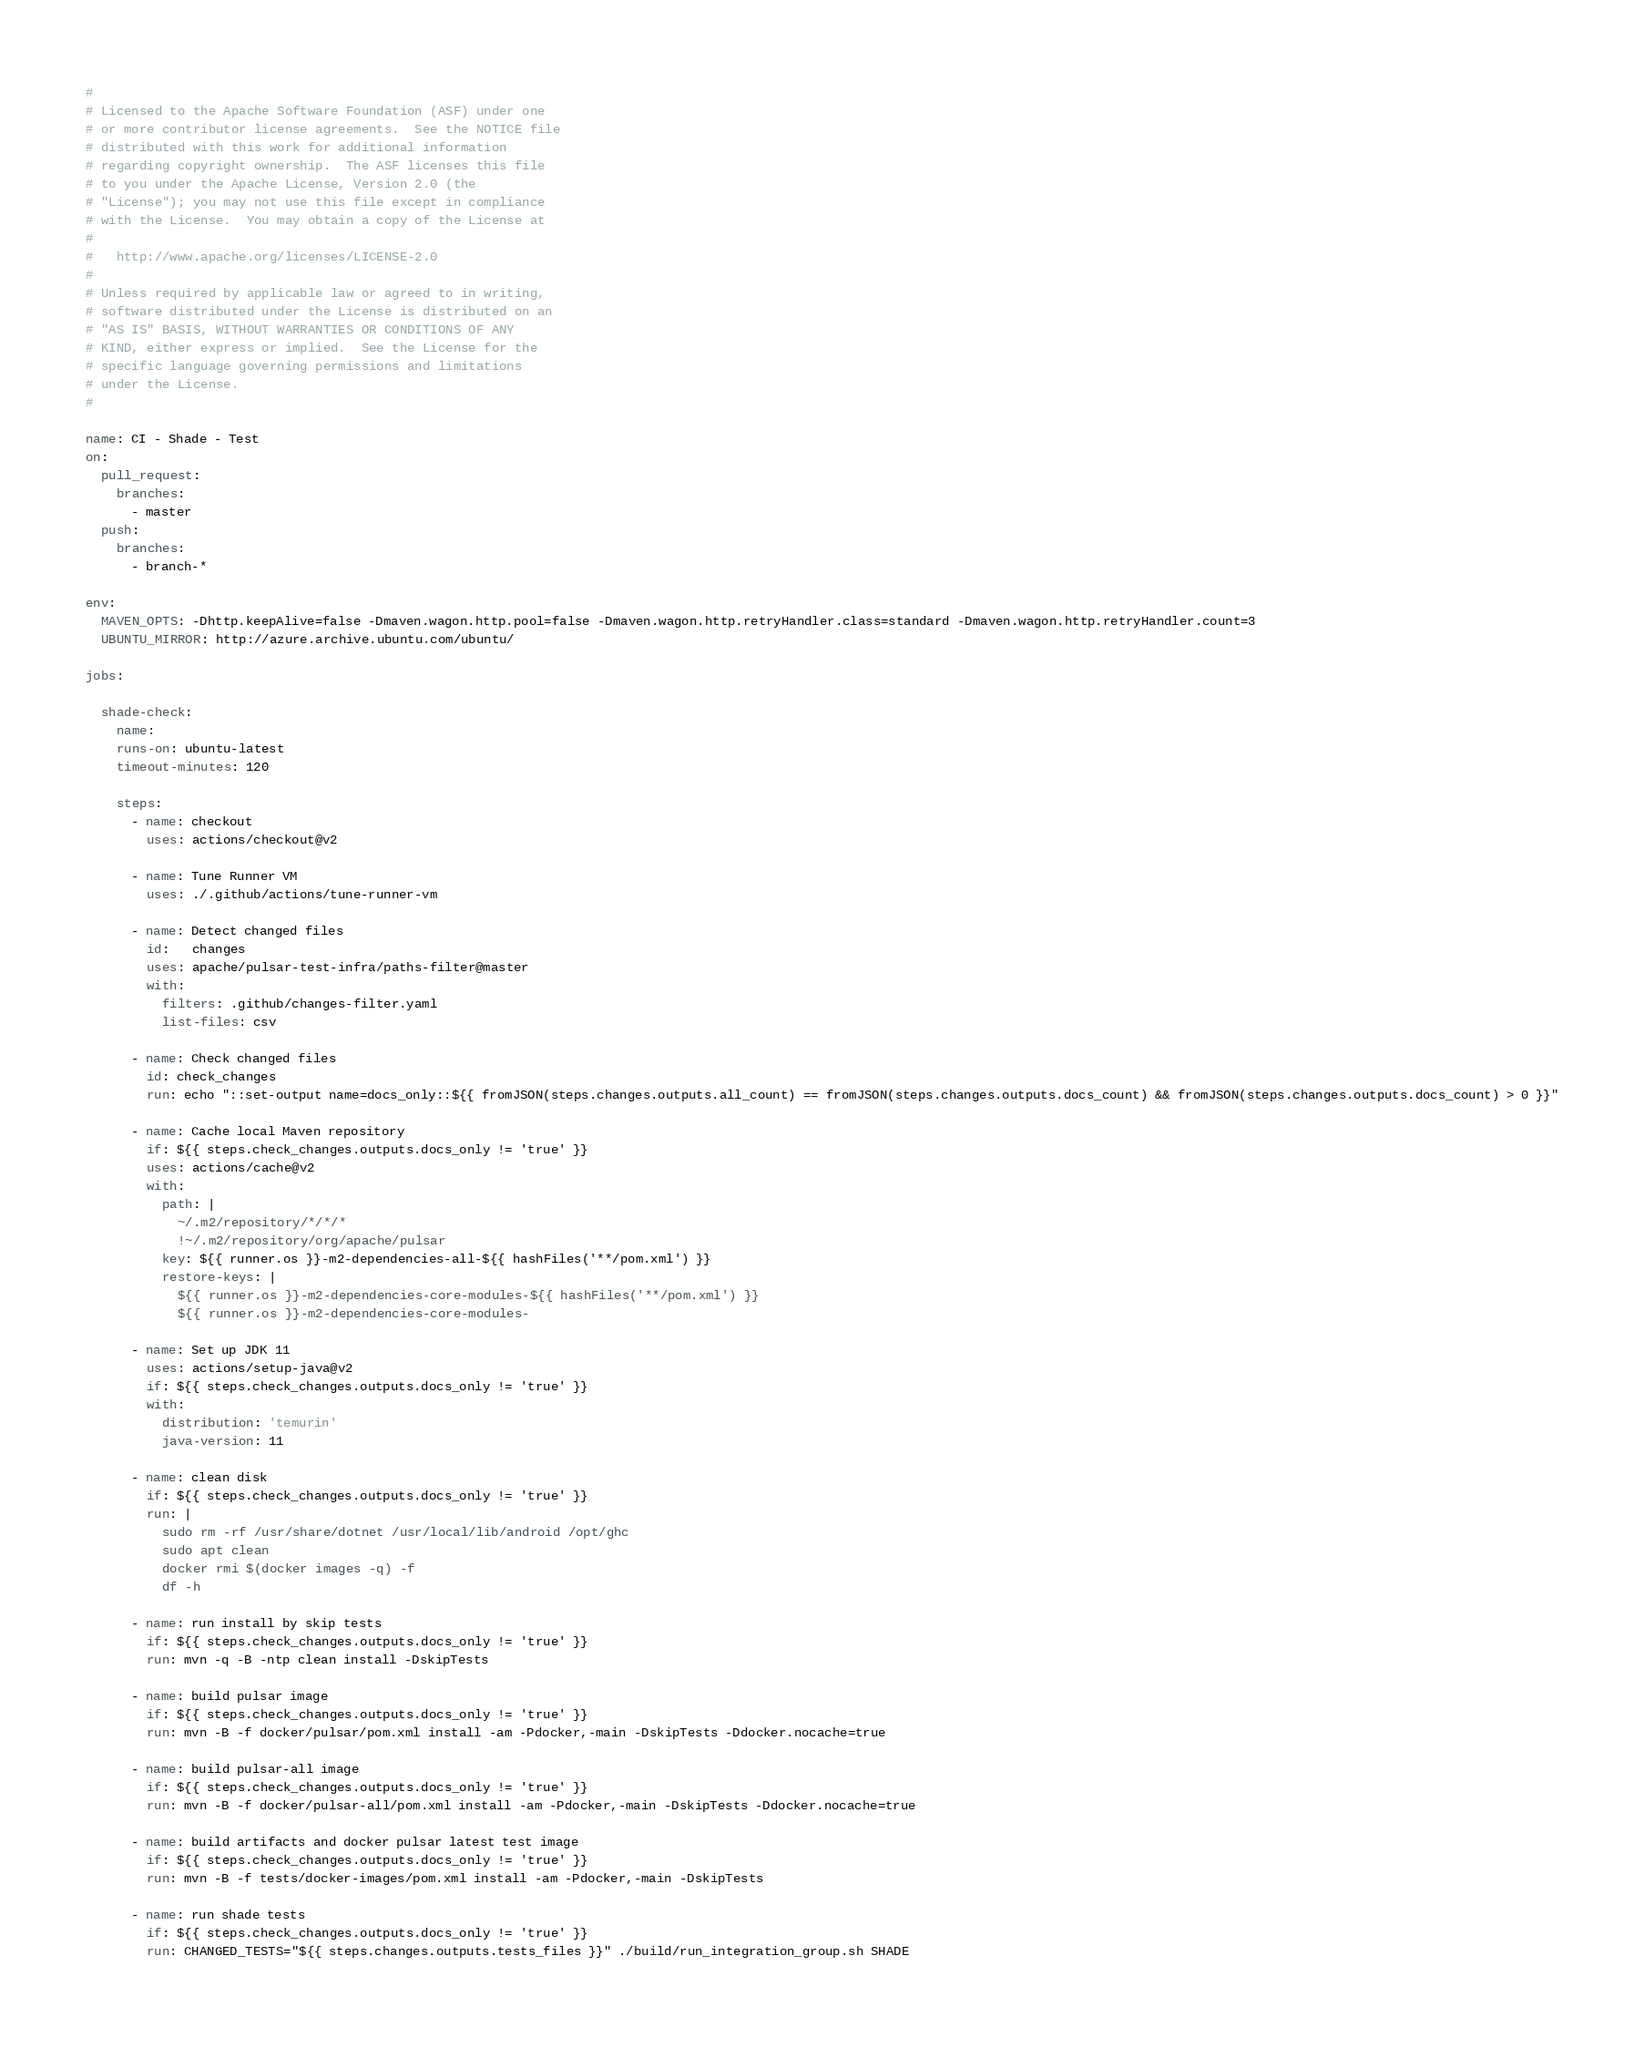Convert code to text. <code><loc_0><loc_0><loc_500><loc_500><_YAML_>#
# Licensed to the Apache Software Foundation (ASF) under one
# or more contributor license agreements.  See the NOTICE file
# distributed with this work for additional information
# regarding copyright ownership.  The ASF licenses this file
# to you under the Apache License, Version 2.0 (the
# "License"); you may not use this file except in compliance
# with the License.  You may obtain a copy of the License at
#
#   http://www.apache.org/licenses/LICENSE-2.0
#
# Unless required by applicable law or agreed to in writing,
# software distributed under the License is distributed on an
# "AS IS" BASIS, WITHOUT WARRANTIES OR CONDITIONS OF ANY
# KIND, either express or implied.  See the License for the
# specific language governing permissions and limitations
# under the License.
#

name: CI - Shade - Test
on:
  pull_request:
    branches:
      - master
  push:
    branches:
      - branch-*

env:
  MAVEN_OPTS: -Dhttp.keepAlive=false -Dmaven.wagon.http.pool=false -Dmaven.wagon.http.retryHandler.class=standard -Dmaven.wagon.http.retryHandler.count=3
  UBUNTU_MIRROR: http://azure.archive.ubuntu.com/ubuntu/

jobs:

  shade-check:
    name:
    runs-on: ubuntu-latest
    timeout-minutes: 120

    steps:
      - name: checkout
        uses: actions/checkout@v2

      - name: Tune Runner VM
        uses: ./.github/actions/tune-runner-vm

      - name: Detect changed files
        id:   changes
        uses: apache/pulsar-test-infra/paths-filter@master
        with:
          filters: .github/changes-filter.yaml
          list-files: csv

      - name: Check changed files
        id: check_changes
        run: echo "::set-output name=docs_only::${{ fromJSON(steps.changes.outputs.all_count) == fromJSON(steps.changes.outputs.docs_count) && fromJSON(steps.changes.outputs.docs_count) > 0 }}"

      - name: Cache local Maven repository
        if: ${{ steps.check_changes.outputs.docs_only != 'true' }}
        uses: actions/cache@v2
        with:
          path: |
            ~/.m2/repository/*/*/*
            !~/.m2/repository/org/apache/pulsar
          key: ${{ runner.os }}-m2-dependencies-all-${{ hashFiles('**/pom.xml') }}
          restore-keys: |
            ${{ runner.os }}-m2-dependencies-core-modules-${{ hashFiles('**/pom.xml') }}
            ${{ runner.os }}-m2-dependencies-core-modules-

      - name: Set up JDK 11
        uses: actions/setup-java@v2
        if: ${{ steps.check_changes.outputs.docs_only != 'true' }}
        with:
          distribution: 'temurin'
          java-version: 11

      - name: clean disk
        if: ${{ steps.check_changes.outputs.docs_only != 'true' }}
        run: |
          sudo rm -rf /usr/share/dotnet /usr/local/lib/android /opt/ghc
          sudo apt clean
          docker rmi $(docker images -q) -f
          df -h

      - name: run install by skip tests
        if: ${{ steps.check_changes.outputs.docs_only != 'true' }}
        run: mvn -q -B -ntp clean install -DskipTests

      - name: build pulsar image
        if: ${{ steps.check_changes.outputs.docs_only != 'true' }}
        run: mvn -B -f docker/pulsar/pom.xml install -am -Pdocker,-main -DskipTests -Ddocker.nocache=true

      - name: build pulsar-all image
        if: ${{ steps.check_changes.outputs.docs_only != 'true' }}
        run: mvn -B -f docker/pulsar-all/pom.xml install -am -Pdocker,-main -DskipTests -Ddocker.nocache=true

      - name: build artifacts and docker pulsar latest test image
        if: ${{ steps.check_changes.outputs.docs_only != 'true' }}
        run: mvn -B -f tests/docker-images/pom.xml install -am -Pdocker,-main -DskipTests

      - name: run shade tests
        if: ${{ steps.check_changes.outputs.docs_only != 'true' }}
        run: CHANGED_TESTS="${{ steps.changes.outputs.tests_files }}" ./build/run_integration_group.sh SHADE
</code> 